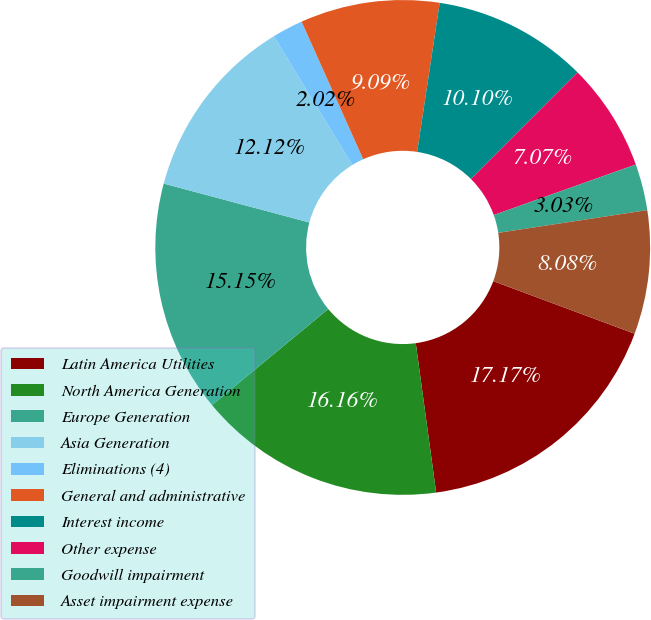Convert chart to OTSL. <chart><loc_0><loc_0><loc_500><loc_500><pie_chart><fcel>Latin America Utilities<fcel>North America Generation<fcel>Europe Generation<fcel>Asia Generation<fcel>Eliminations (4)<fcel>General and administrative<fcel>Interest income<fcel>Other expense<fcel>Goodwill impairment<fcel>Asset impairment expense<nl><fcel>17.17%<fcel>16.16%<fcel>15.15%<fcel>12.12%<fcel>2.02%<fcel>9.09%<fcel>10.1%<fcel>7.07%<fcel>3.03%<fcel>8.08%<nl></chart> 